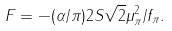<formula> <loc_0><loc_0><loc_500><loc_500>F = - ( \alpha / \pi ) 2 S \sqrt { 2 } \mu _ { \pi } ^ { 2 } / f _ { \pi } .</formula> 